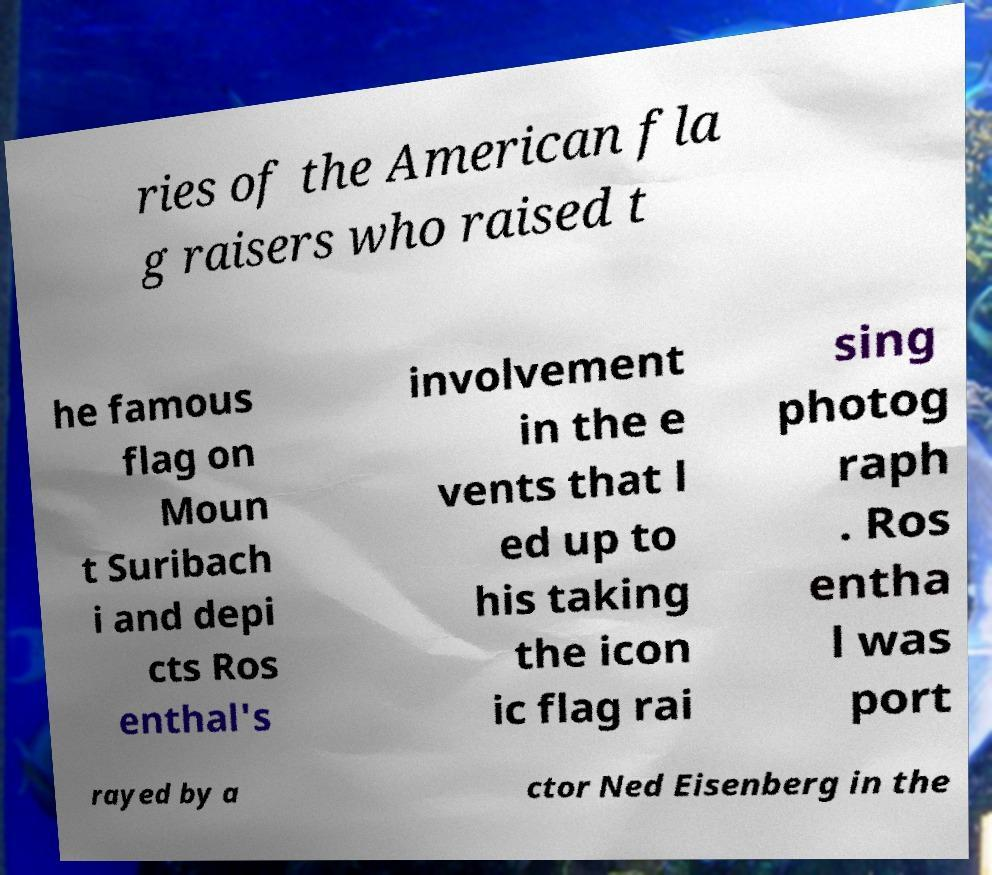Could you extract and type out the text from this image? ries of the American fla g raisers who raised t he famous flag on Moun t Suribach i and depi cts Ros enthal's involvement in the e vents that l ed up to his taking the icon ic flag rai sing photog raph . Ros entha l was port rayed by a ctor Ned Eisenberg in the 